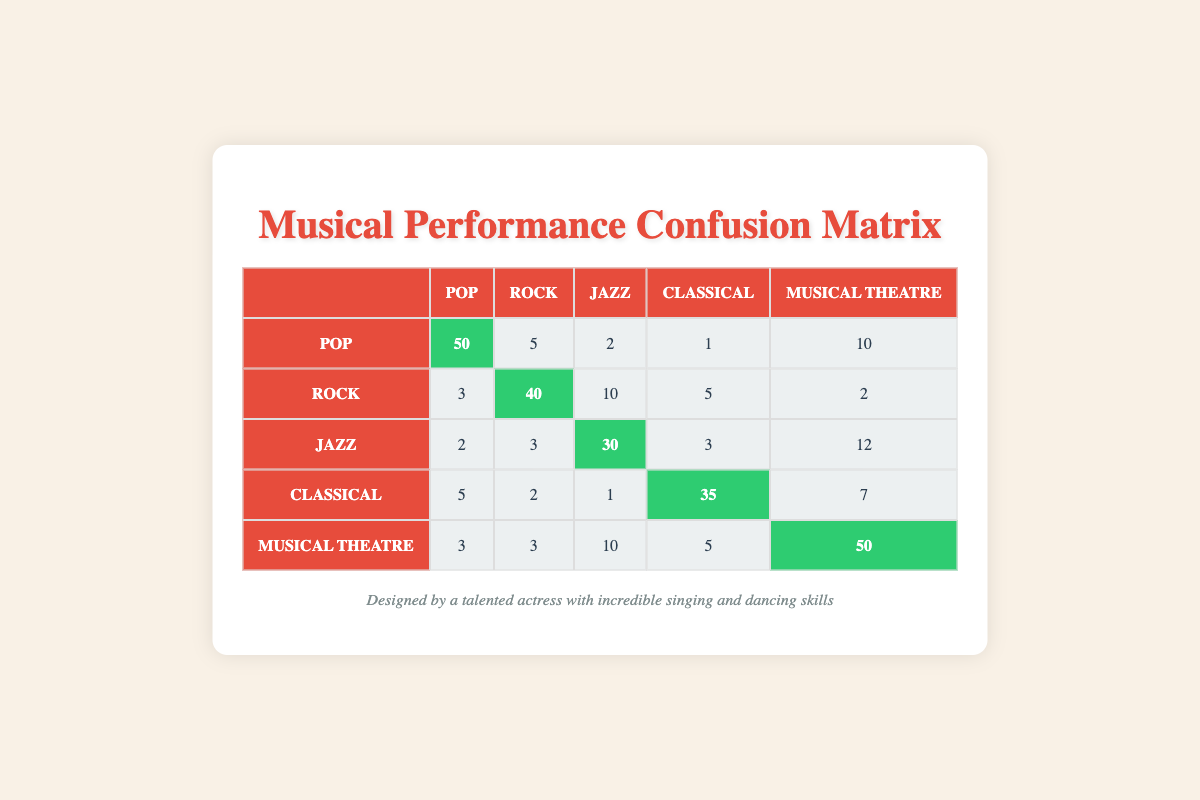What is the accuracy for the Pop genre? To find the accuracy for the Pop genre, look at the diagonal value, which represents true positives. In this case, the value is 50.
Answer: 50 How many times was Musical Theatre misclassified as Jazz? To find this, look at the intersection of the Musical Theatre row and Jazz column. The value is 10.
Answer: 10 What is the total predicted performance for the Rock genre? Sum the predicted values for the Rock row: 3 + 40 + 10 + 5 + 2 = 60.
Answer: 60 Is it true that Classical had more accurate predictions than Rock? The correct prediction for Classical is 35, while for Rock it is 40. Since 35 is less than 40, this statement is false.
Answer: No What is the average misclassification rate across all genres? To calculate this, first find the sum of all off-diagonal elements (misclassifications). Pop: 5 + 2 + 1 + 10 = 18; Rock: 3 + 10 + 5 + 2 = 20; Jazz: 2 + 3 + 3 + 12 = 20; Classical: 5 + 2 + 1 + 7 = 15; Musical Theatre: 3 + 3 + 10 + 5 = 21. Total misclassifications = 18 + 20 + 20 + 15 + 21 = 94. The total number of predictions is 50 + 60 + 30 + 35 + 50 = 225. Average misclassification rate = 94/225 ≈ 0.418 or 41.8%.
Answer: 41.8% 